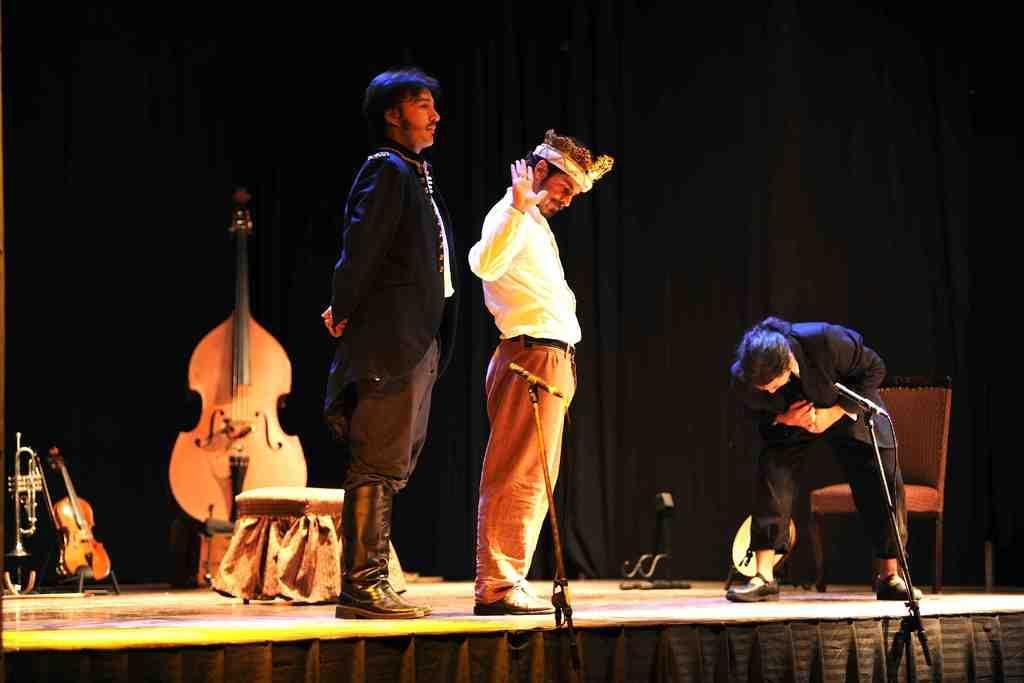Describe this image in one or two sentences. In this picture there are three people standing on the stage and there are musical instruments and there is a chair and there is a stool on the stage. At the back there is a black curtain. 